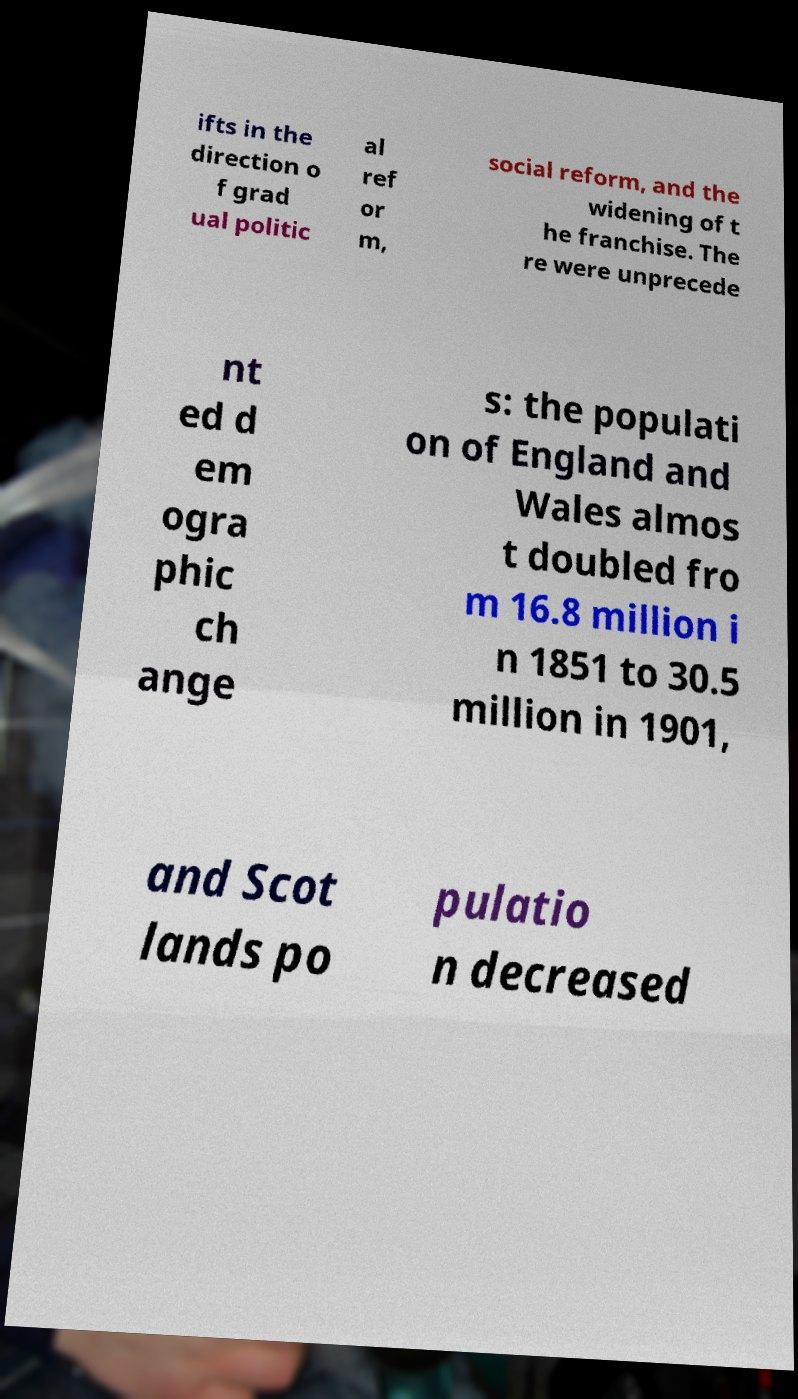Could you extract and type out the text from this image? ifts in the direction o f grad ual politic al ref or m, social reform, and the widening of t he franchise. The re were unprecede nt ed d em ogra phic ch ange s: the populati on of England and Wales almos t doubled fro m 16.8 million i n 1851 to 30.5 million in 1901, and Scot lands po pulatio n decreased 